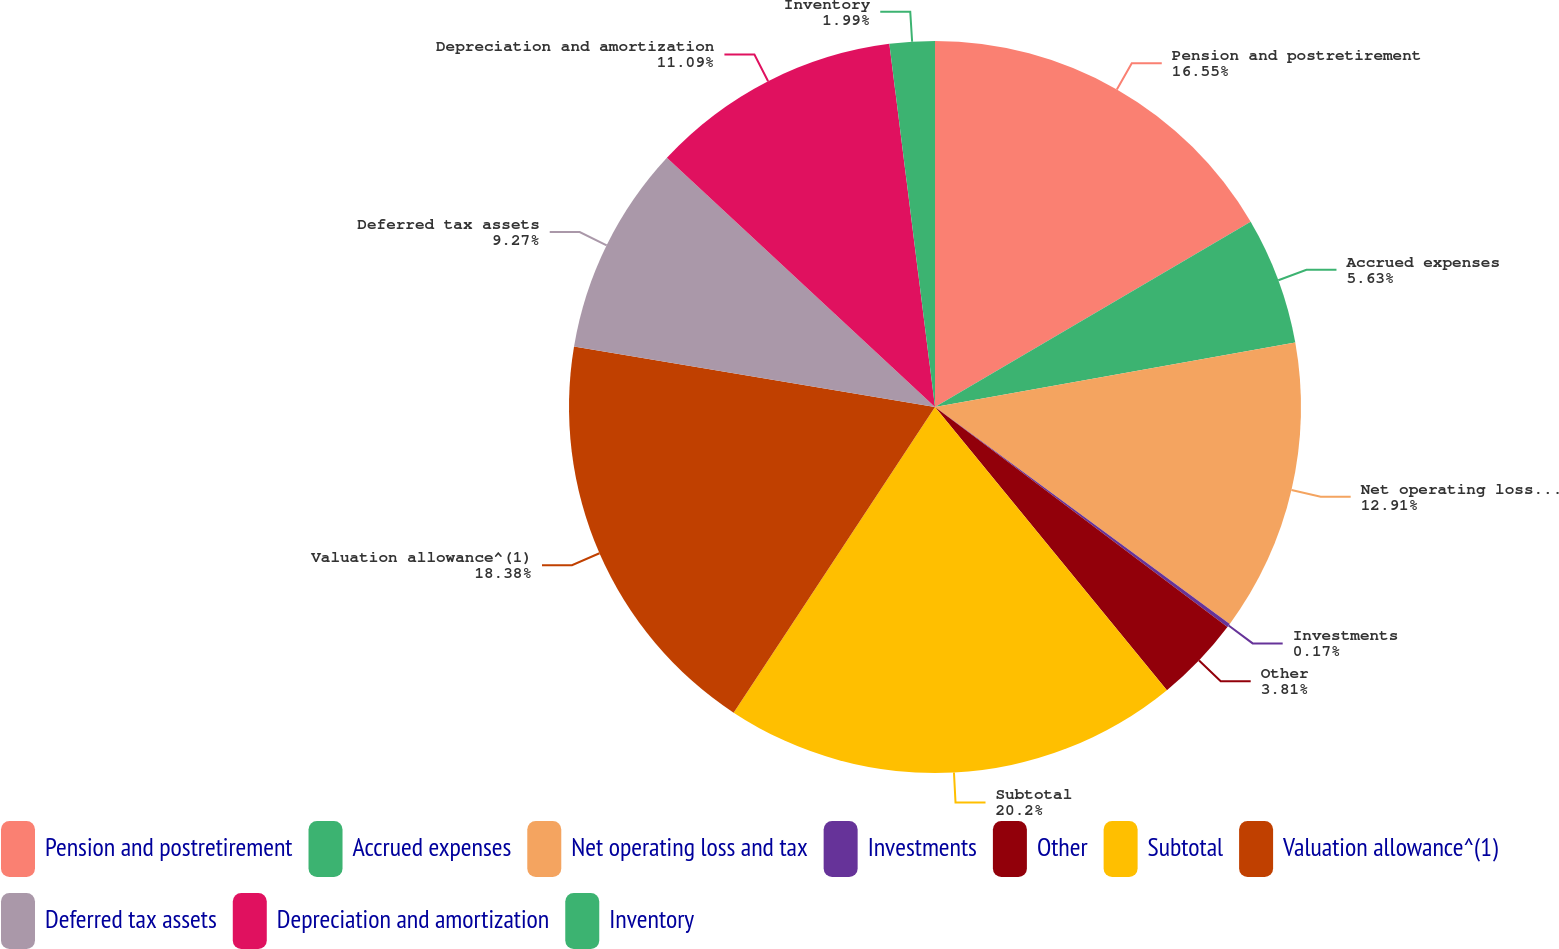Convert chart. <chart><loc_0><loc_0><loc_500><loc_500><pie_chart><fcel>Pension and postretirement<fcel>Accrued expenses<fcel>Net operating loss and tax<fcel>Investments<fcel>Other<fcel>Subtotal<fcel>Valuation allowance^(1)<fcel>Deferred tax assets<fcel>Depreciation and amortization<fcel>Inventory<nl><fcel>16.55%<fcel>5.63%<fcel>12.91%<fcel>0.17%<fcel>3.81%<fcel>20.19%<fcel>18.37%<fcel>9.27%<fcel>11.09%<fcel>1.99%<nl></chart> 